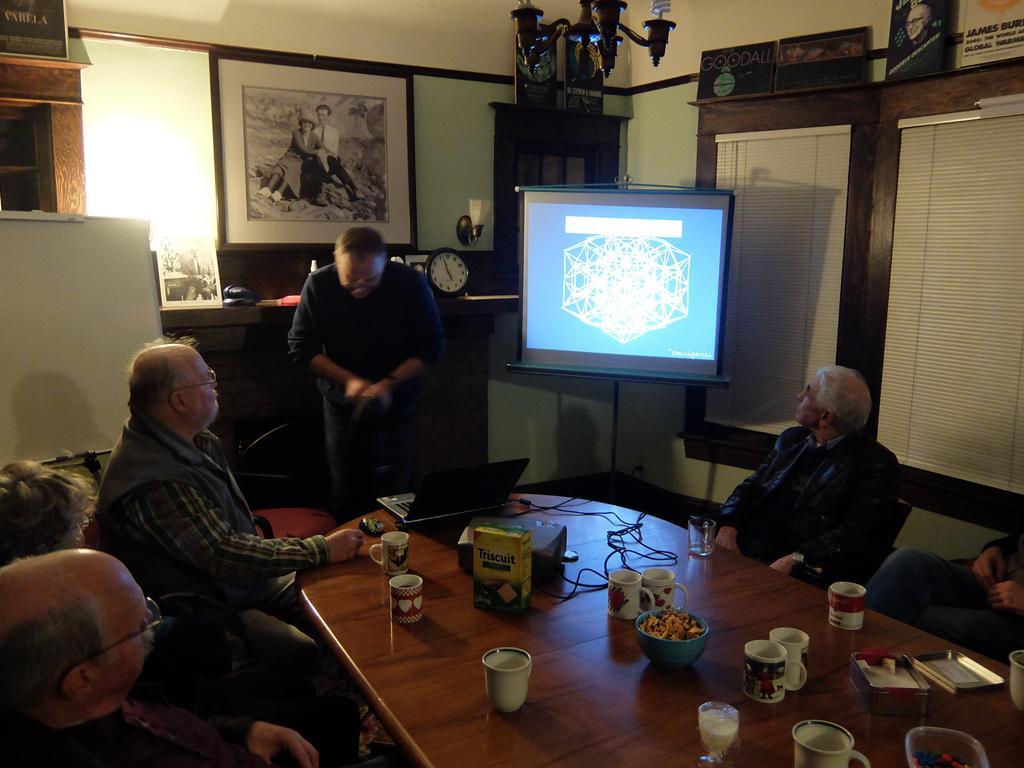In one or two sentences, can you explain what this image depicts? We can see photo frame, light and boards on a wall. This is a ceiling light. Here we can see a television. We can see persons sitting on chairs in front of a table and on the table we can see glasses, biscuit pack, bowl of snacks, box, cups. Here we can see one man standing near to the table. This is a whiteboard. 